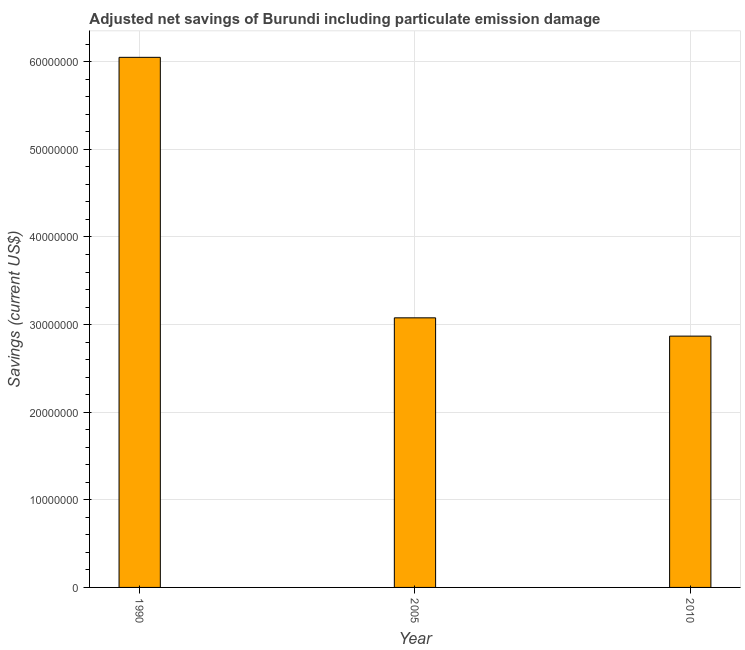Does the graph contain grids?
Offer a terse response. Yes. What is the title of the graph?
Keep it short and to the point. Adjusted net savings of Burundi including particulate emission damage. What is the label or title of the Y-axis?
Your response must be concise. Savings (current US$). What is the adjusted net savings in 1990?
Give a very brief answer. 6.05e+07. Across all years, what is the maximum adjusted net savings?
Provide a succinct answer. 6.05e+07. Across all years, what is the minimum adjusted net savings?
Your answer should be very brief. 2.87e+07. In which year was the adjusted net savings maximum?
Offer a very short reply. 1990. In which year was the adjusted net savings minimum?
Ensure brevity in your answer.  2010. What is the sum of the adjusted net savings?
Your response must be concise. 1.20e+08. What is the difference between the adjusted net savings in 1990 and 2005?
Provide a succinct answer. 2.97e+07. What is the average adjusted net savings per year?
Give a very brief answer. 4.00e+07. What is the median adjusted net savings?
Offer a very short reply. 3.08e+07. What is the ratio of the adjusted net savings in 2005 to that in 2010?
Make the answer very short. 1.07. Is the difference between the adjusted net savings in 1990 and 2005 greater than the difference between any two years?
Offer a very short reply. No. What is the difference between the highest and the second highest adjusted net savings?
Your answer should be very brief. 2.97e+07. What is the difference between the highest and the lowest adjusted net savings?
Ensure brevity in your answer.  3.18e+07. How many bars are there?
Offer a terse response. 3. What is the Savings (current US$) in 1990?
Your response must be concise. 6.05e+07. What is the Savings (current US$) of 2005?
Provide a succinct answer. 3.08e+07. What is the Savings (current US$) of 2010?
Your response must be concise. 2.87e+07. What is the difference between the Savings (current US$) in 1990 and 2005?
Provide a succinct answer. 2.97e+07. What is the difference between the Savings (current US$) in 1990 and 2010?
Offer a very short reply. 3.18e+07. What is the difference between the Savings (current US$) in 2005 and 2010?
Offer a terse response. 2.09e+06. What is the ratio of the Savings (current US$) in 1990 to that in 2005?
Give a very brief answer. 1.97. What is the ratio of the Savings (current US$) in 1990 to that in 2010?
Your response must be concise. 2.11. What is the ratio of the Savings (current US$) in 2005 to that in 2010?
Your response must be concise. 1.07. 